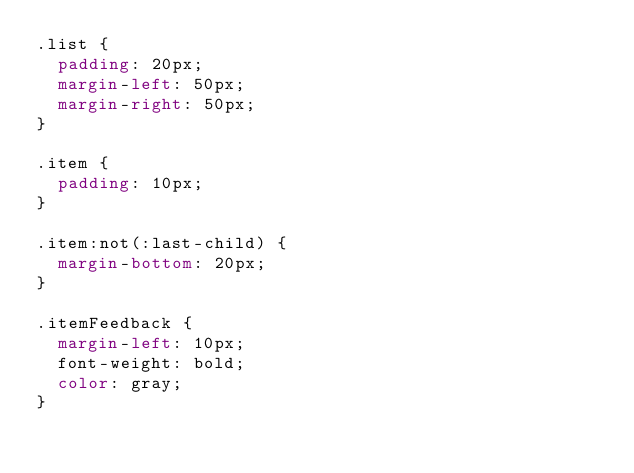Convert code to text. <code><loc_0><loc_0><loc_500><loc_500><_CSS_>.list {
  padding: 20px;
  margin-left: 50px;
  margin-right: 50px;
}

.item {
  padding: 10px;
}

.item:not(:last-child) {
  margin-bottom: 20px;
}

.itemFeedback {
  margin-left: 10px;
  font-weight: bold;
  color: gray;
}
</code> 